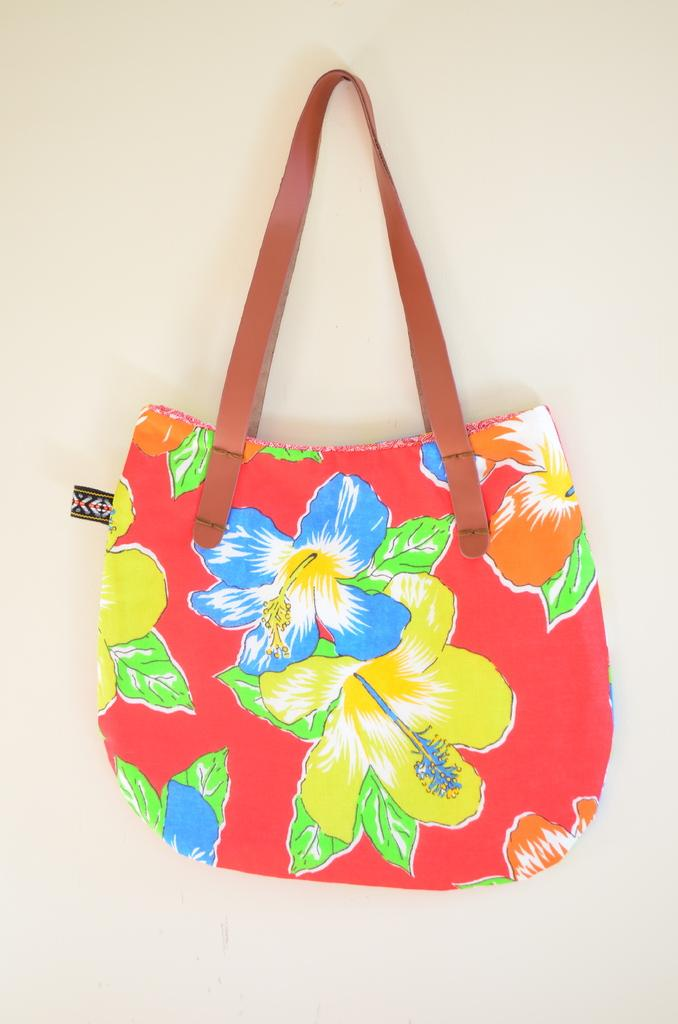What type of object is in the image? There is a colorful bag in the image. What design is featured on the bag? The bag has blue and yellow flowers painted on it. What color is the belt on the bag? The bag has a red color belt. How many snails can be seen crawling on the bag in the image? There are no snails present on the bag in the image. 